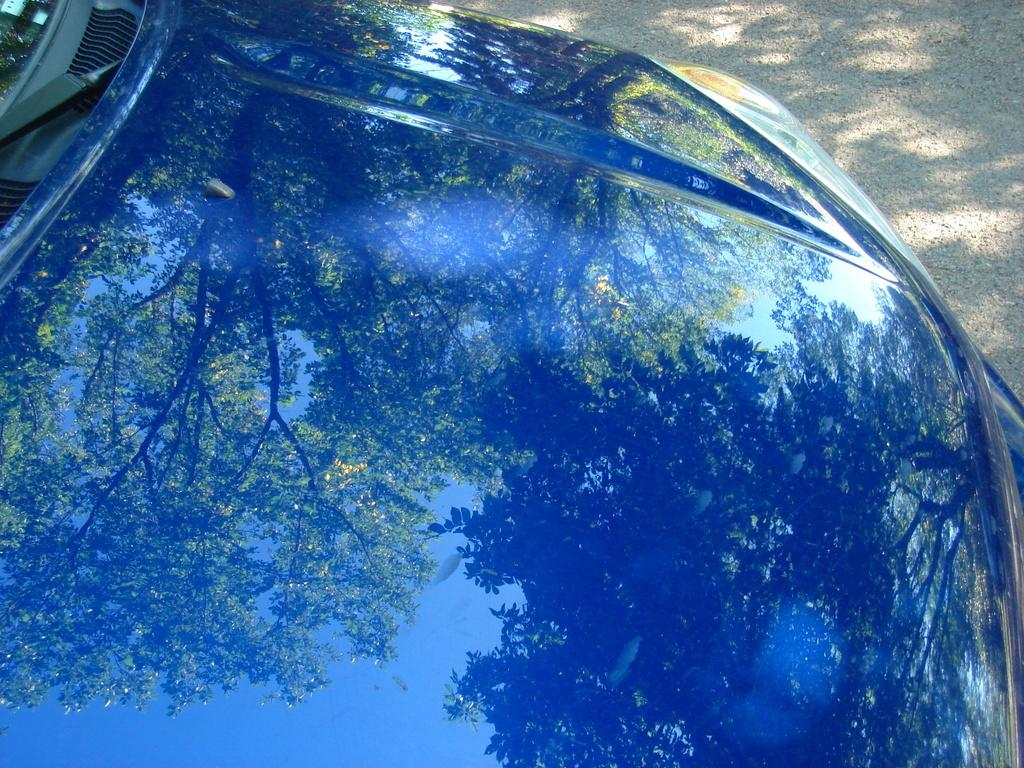What is the main subject of the image? There is a car in the image. Where is the car located in the image? The car is in the center of the image. What can be seen in the top right corner of the image? The top right corner of the image contains a road. What type of hate can be seen in the image? There is no hate present in the image; it features a car in the center and a road in the top right corner. 